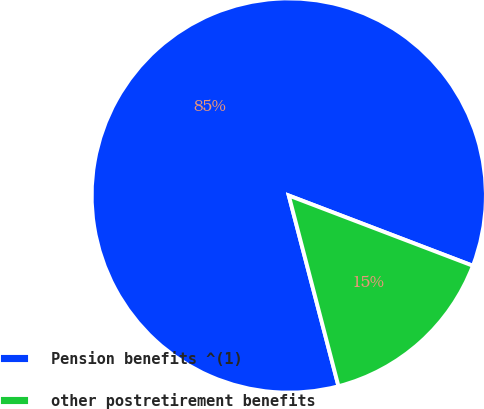<chart> <loc_0><loc_0><loc_500><loc_500><pie_chart><fcel>Pension benefits ^(1)<fcel>other postretirement benefits<nl><fcel>84.86%<fcel>15.14%<nl></chart> 